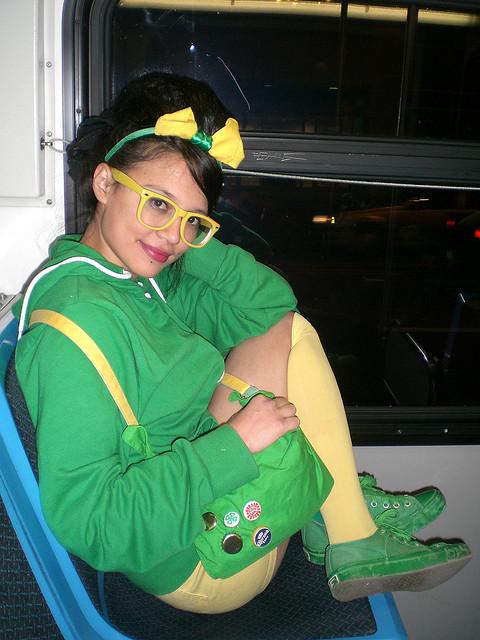What group does this person belong to?
Write a very short answer. Girl scouts. Why is this just wrong?
Short answer required. It's not. Are these normal work clothes?
Give a very brief answer. No. How many badges are on her purse?
Be succinct. 5. 